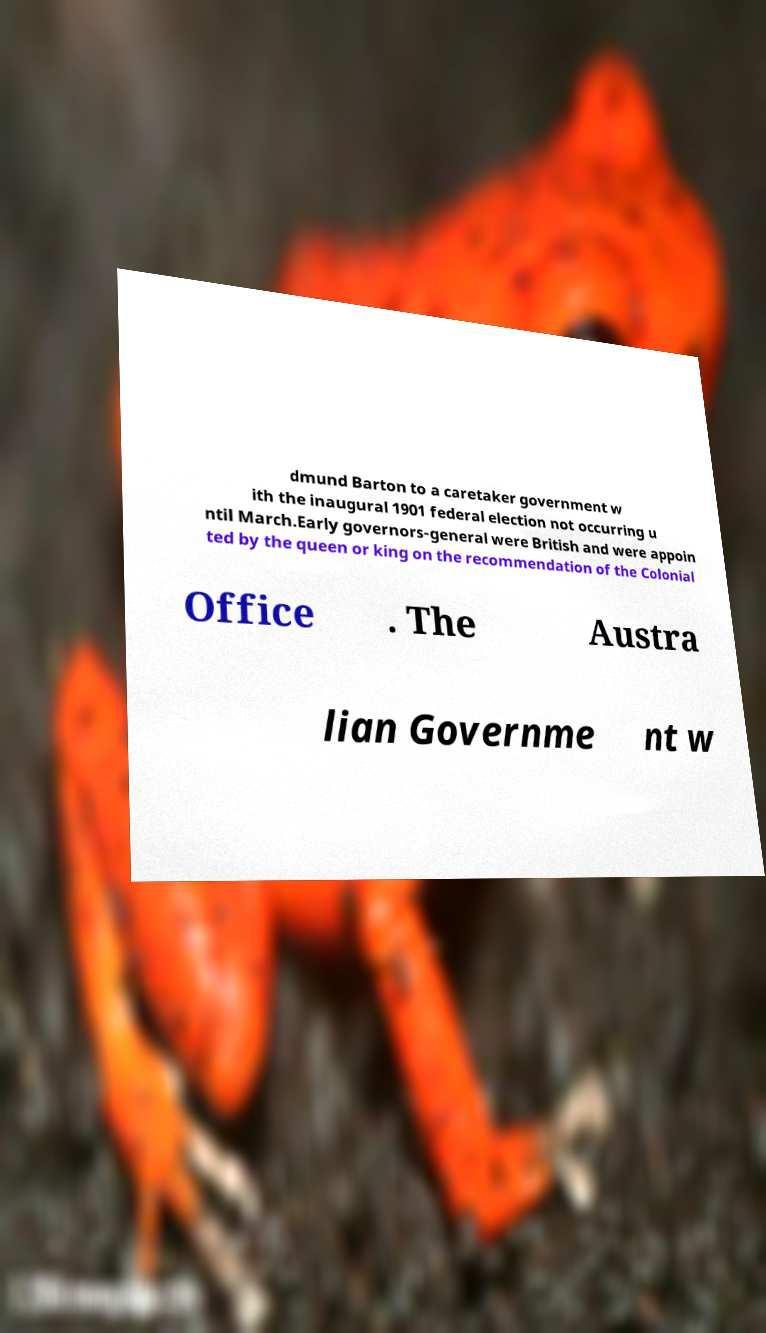Please read and relay the text visible in this image. What does it say? dmund Barton to a caretaker government w ith the inaugural 1901 federal election not occurring u ntil March.Early governors-general were British and were appoin ted by the queen or king on the recommendation of the Colonial Office . The Austra lian Governme nt w 